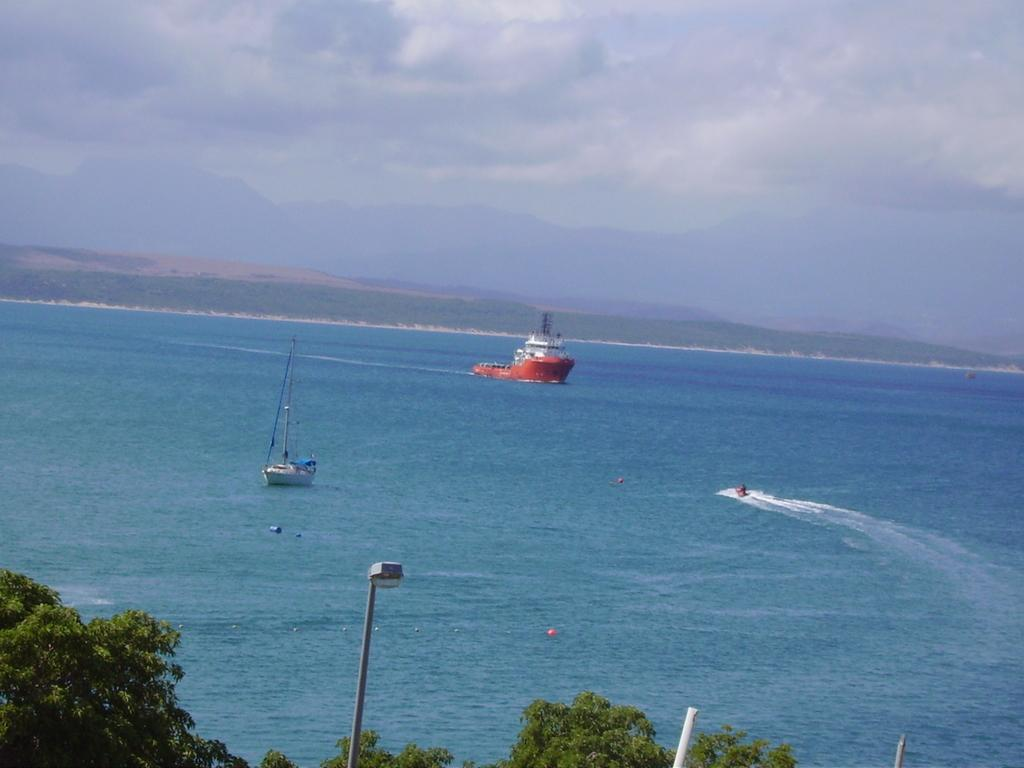What type of watercraft can be seen in the image? There is a ship and a boat in the image. Where are the ship and boat located? Both the ship and boat are on the water in the image. What can be seen at the bottom of the image? There are trees and a light pole at the bottom of the image. What is visible in the background of the image? Hills and the sky are visible in the background of the image. What can be observed in the sky? Clouds are present in the sky. What type of cream is being used to paint the band in the image? There is no band or cream present in the image. What type of bean is growing on the hills in the background of the image? There are no beans visible in the image; only hills can be seen in the background. 